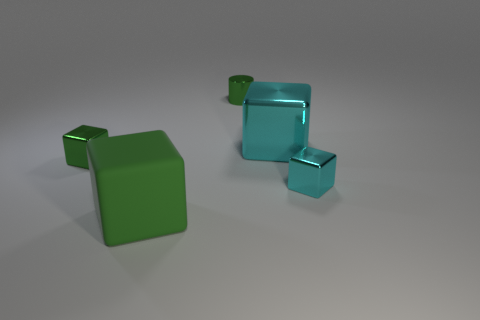Subtract 1 cubes. How many cubes are left? 3 Subtract all green blocks. Subtract all purple balls. How many blocks are left? 2 Add 3 red metal cubes. How many objects exist? 8 Subtract all cubes. How many objects are left? 1 Add 1 big cyan metal blocks. How many big cyan metal blocks are left? 2 Add 4 tiny cyan metallic things. How many tiny cyan metallic things exist? 5 Subtract 0 yellow cubes. How many objects are left? 5 Subtract all tiny things. Subtract all large green cubes. How many objects are left? 1 